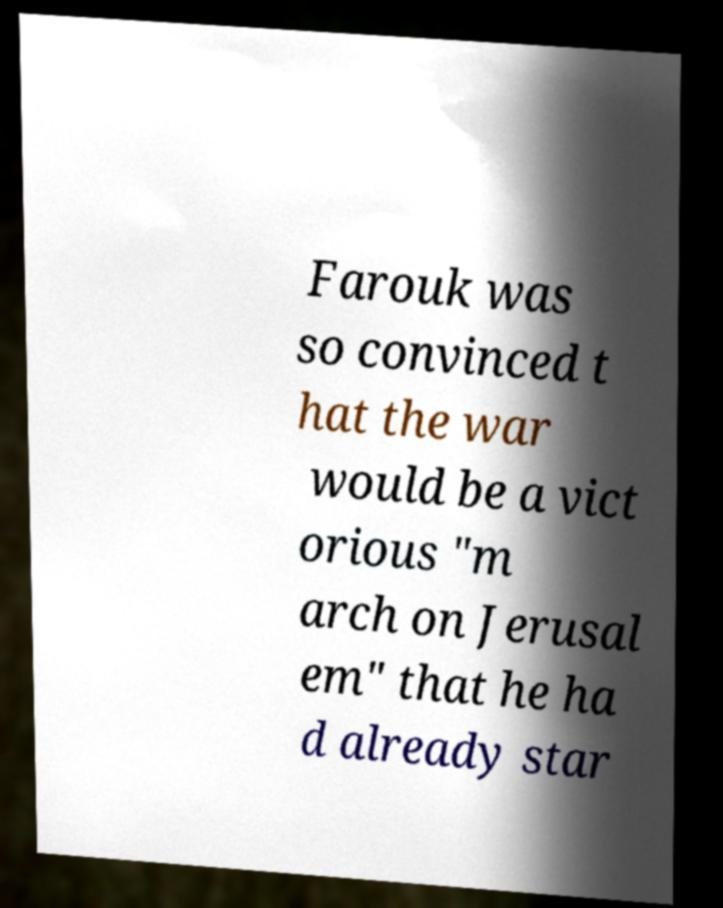For documentation purposes, I need the text within this image transcribed. Could you provide that? Farouk was so convinced t hat the war would be a vict orious "m arch on Jerusal em" that he ha d already star 